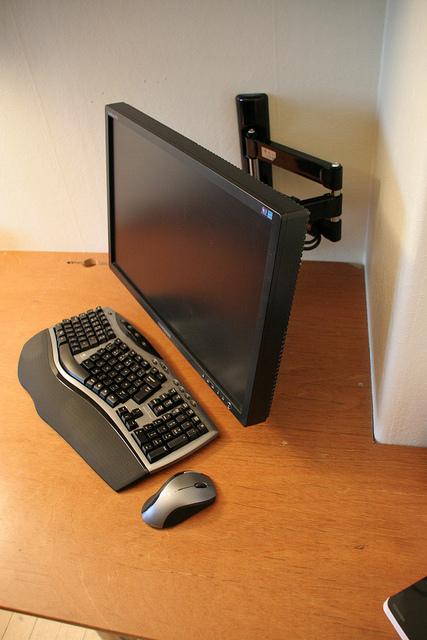What is on top of the table?
Answer briefly. Keyboard and mouse. Is the keyboard black or white?
Be succinct. Black. How is the monitor attached to the wall?
Concise answer only. Wall mount. Is there a book on the desk?
Short answer required. No. Is the monitor on or off?
Be succinct. Off. Is the desk messy?
Quick response, please. No. Is the mouse wireless?
Concise answer only. Yes. 